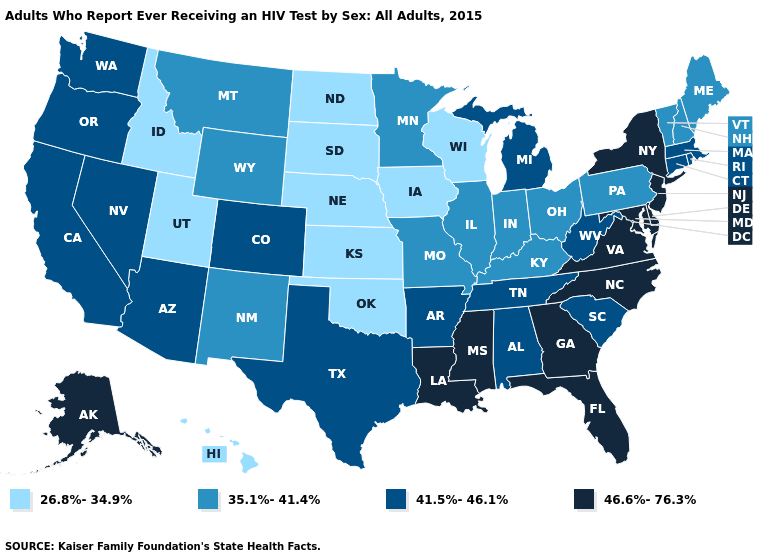What is the value of Washington?
Give a very brief answer. 41.5%-46.1%. Does the first symbol in the legend represent the smallest category?
Keep it brief. Yes. What is the value of North Dakota?
Keep it brief. 26.8%-34.9%. Does New Mexico have the lowest value in the West?
Answer briefly. No. Name the states that have a value in the range 35.1%-41.4%?
Answer briefly. Illinois, Indiana, Kentucky, Maine, Minnesota, Missouri, Montana, New Hampshire, New Mexico, Ohio, Pennsylvania, Vermont, Wyoming. Does Oklahoma have the lowest value in the USA?
Give a very brief answer. Yes. Does the first symbol in the legend represent the smallest category?
Be succinct. Yes. Name the states that have a value in the range 46.6%-76.3%?
Quick response, please. Alaska, Delaware, Florida, Georgia, Louisiana, Maryland, Mississippi, New Jersey, New York, North Carolina, Virginia. Does New Hampshire have a lower value than Kentucky?
Keep it brief. No. What is the highest value in states that border Vermont?
Answer briefly. 46.6%-76.3%. Among the states that border South Dakota , does Iowa have the lowest value?
Short answer required. Yes. Does South Dakota have the lowest value in the USA?
Write a very short answer. Yes. What is the value of Virginia?
Be succinct. 46.6%-76.3%. Name the states that have a value in the range 35.1%-41.4%?
Give a very brief answer. Illinois, Indiana, Kentucky, Maine, Minnesota, Missouri, Montana, New Hampshire, New Mexico, Ohio, Pennsylvania, Vermont, Wyoming. Is the legend a continuous bar?
Give a very brief answer. No. 